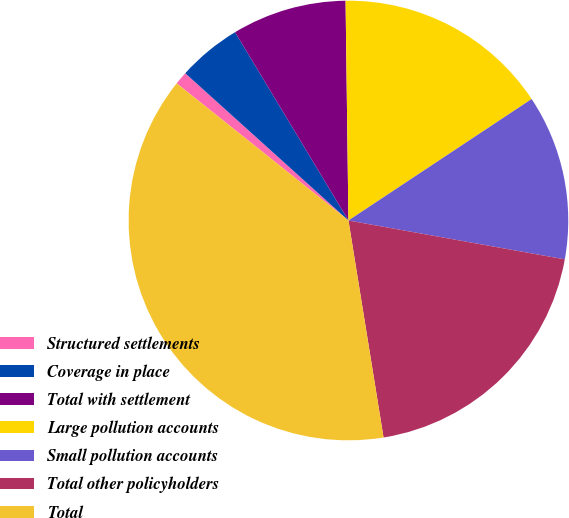Convert chart. <chart><loc_0><loc_0><loc_500><loc_500><pie_chart><fcel>Structured settlements<fcel>Coverage in place<fcel>Total with settlement<fcel>Large pollution accounts<fcel>Small pollution accounts<fcel>Total other policyholders<fcel>Total<nl><fcel>0.96%<fcel>4.69%<fcel>8.42%<fcel>15.89%<fcel>12.15%<fcel>19.62%<fcel>38.28%<nl></chart> 